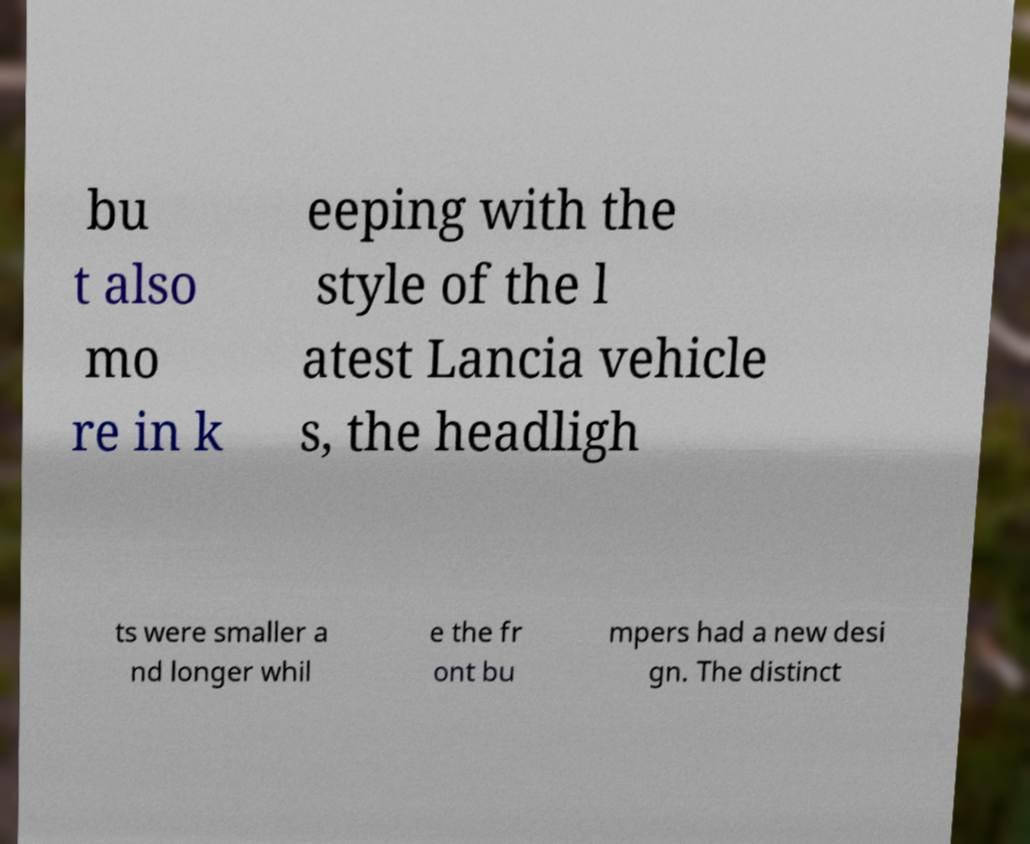Could you assist in decoding the text presented in this image and type it out clearly? bu t also mo re in k eeping with the style of the l atest Lancia vehicle s, the headligh ts were smaller a nd longer whil e the fr ont bu mpers had a new desi gn. The distinct 